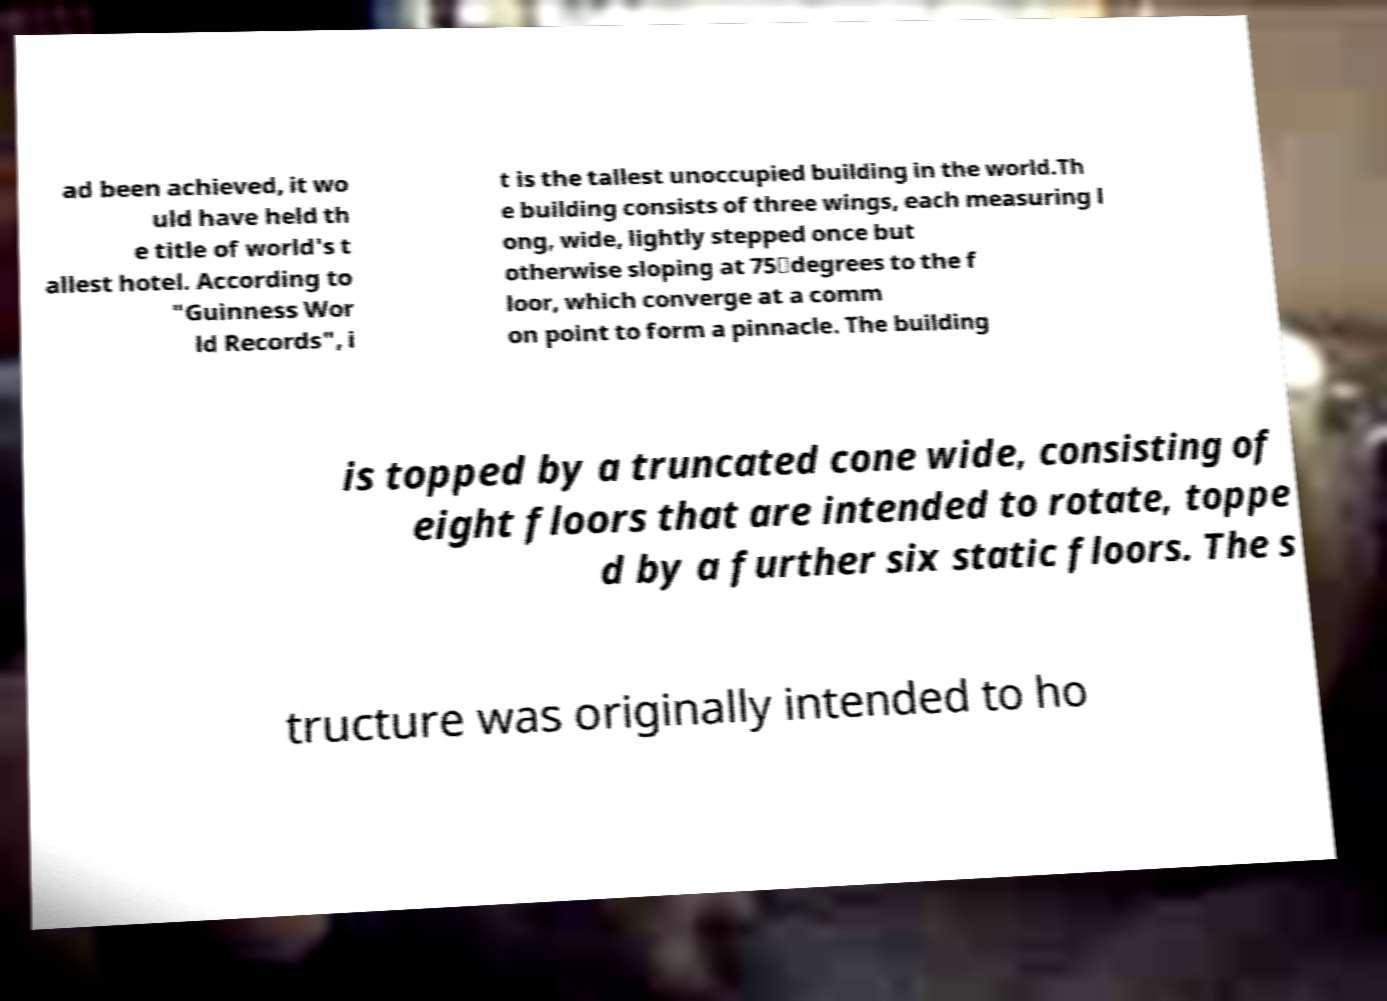I need the written content from this picture converted into text. Can you do that? ad been achieved, it wo uld have held th e title of world's t allest hotel. According to "Guinness Wor ld Records", i t is the tallest unoccupied building in the world.Th e building consists of three wings, each measuring l ong, wide, lightly stepped once but otherwise sloping at 75‑degrees to the f loor, which converge at a comm on point to form a pinnacle. The building is topped by a truncated cone wide, consisting of eight floors that are intended to rotate, toppe d by a further six static floors. The s tructure was originally intended to ho 